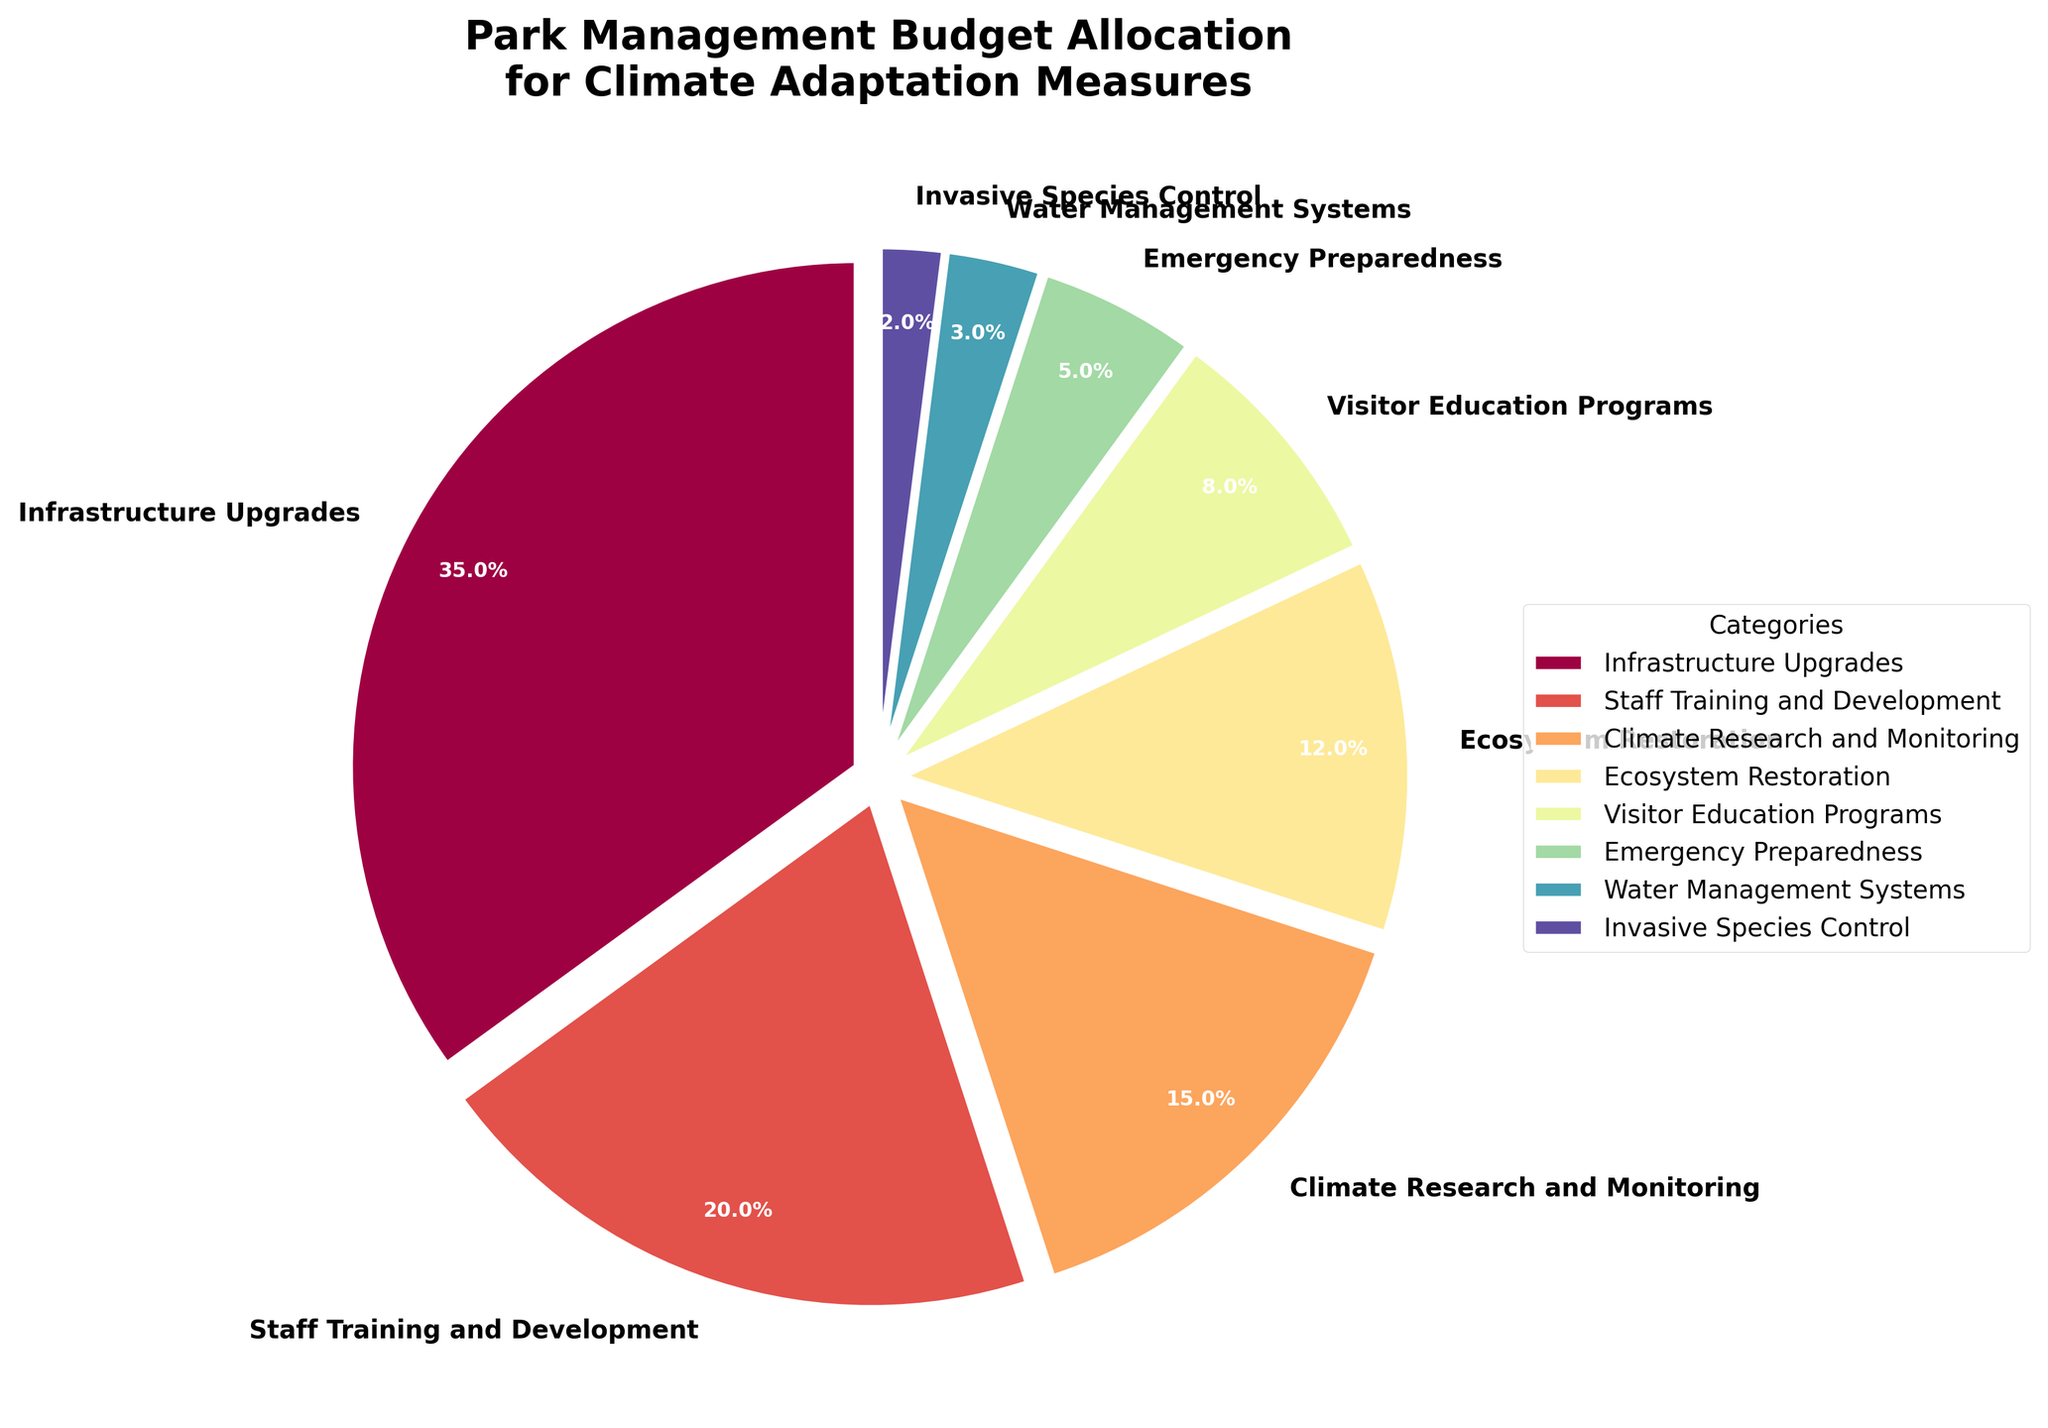Which category receives the highest budget allocation? By visually inspecting the pie chart, the largest segment corresponds to 'Infrastructure Upgrades'.
Answer: Infrastructure Upgrades Which budget allocation is the smallest? The smallest segment in the pie chart corresponds to 'Invasive Species Control'.
Answer: Invasive Species Control How much more budget does 'Infrastructure Upgrades' receive compared to 'Staff Training and Development'? 'Infrastructure Upgrades' receives 35%, and 'Staff Training and Development' receives 20%. The difference is 35% - 20% = 15%.
Answer: 15% How much combined budget is allocated for 'Climate Research and Monitoring' and 'Ecosystem Restoration'? 'Climate Research and Monitoring' has 15%, and 'Ecosystem Restoration' has 12%. Their combined allocation is 15% + 12% = 27%.
Answer: 27% What percentage of the budget is allocated to education and preparedness, combining 'Visitor Education Programs' and 'Emergency Preparedness'? 'Visitor Education Programs' has 8%, and 'Emergency Preparedness' has 5%. Their combined allocation is 8% + 5% = 13%.
Answer: 13% What is the second largest budget allocation category? The second largest segment after 'Infrastructure Upgrades' is 'Staff Training and Development', which corresponds to a budget allocation of 20%.
Answer: Staff Training and Development Compare the budget allocations for 'Water Management Systems' and 'Invasive Species Control'. Which receives more and by how much? 'Water Management Systems' receives 3%, while 'Invasive Species Control' receives 2%. 'Water Management Systems' receives 1% more.
Answer: Water Management Systems by 1% Which categories combined receive a budget less than 'Staff Training and Development'? 'Staff Training and Development' receives 20%. 'Ecosystem Restoration' (12%), 'Visitor Education Programs' (8%), 'Emergency Preparedness' (5%), 'Water Management Systems' (3%), and 'Invasive Species Control' (2%) can be combined to make up 30%, which exceeds 20%. However, individually, and up to three categories can be combined without exceeding 20%.
Answer: Various category combinations, e.g., 'Ecosystem Restoration', 'Visitor Education Programs', and 'Emergency Preparedness' receive together less than 20% What is the color of the segment representing 'Ecosystem Restoration'? Each segment of the pie chart is colored with a custom color palette, and 'Ecosystem Restoration' can be visually identified with its specific color, which will be a distinct color like others. For example, if shades of red, orange, yellow, green, blue, etc., have been used, 'Ecosystem Restoration' could correspond to a specific color among those.
Answer: Depends on the palette (e.g., green if identified as such) 